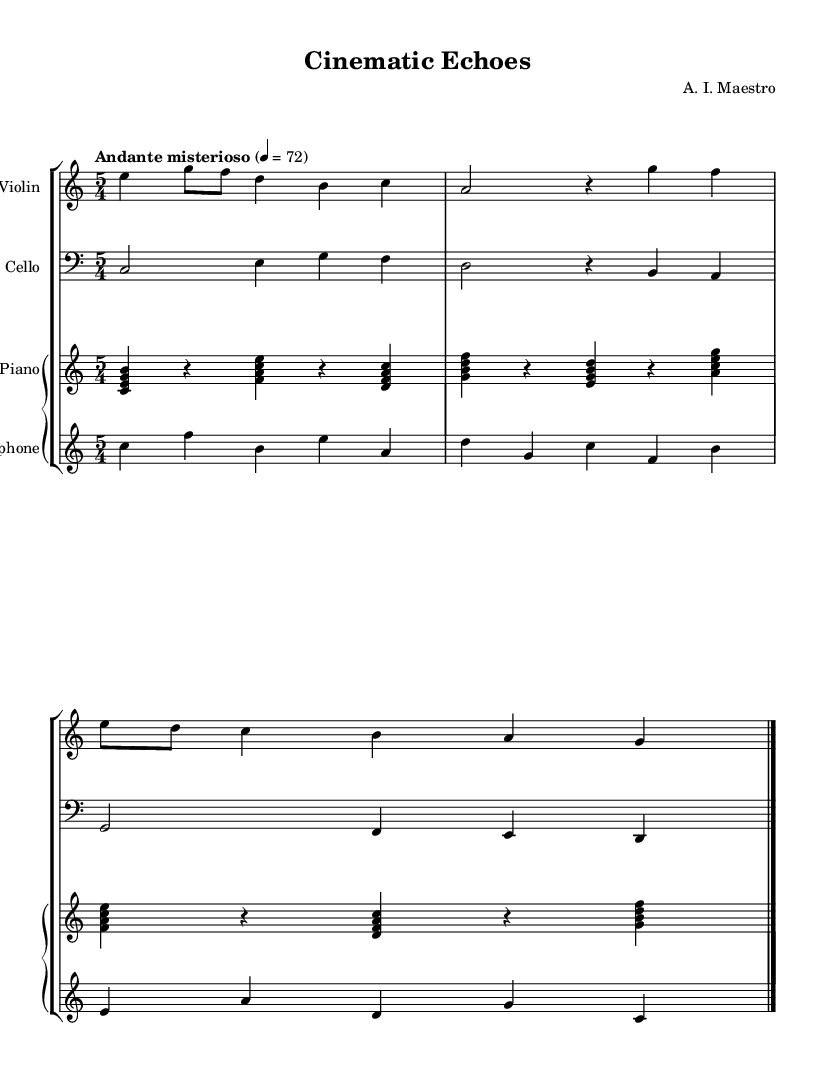What is the time signature of this music? The time signature is indicated at the beginning of the piece, written as "5/4." This means there are five beats in each measure, and a quarter note receives one beat.
Answer: 5/4 What is the tempo marking for this composition? The tempo marking is found at the start of the score, which states "Andante misterioso" and indicates a tempo of 72 beats per minute. "Andante" suggests a moderately slow pace.
Answer: Andante misterioso How many instruments are featured in this composition? The score displays four staves, each representing an instrument, specifically violin, cello, prepared piano, and vibraphone. This indicates there are four instruments used in the performance.
Answer: Four What is the clef used for the cello part? The cello part is notated in the bass clef, which is indicated at the start of the cello staff. The bass clef is commonly used for lower-pitched instruments like the cello.
Answer: Bass clef Which instruments are indicated to use pedal sustain? The score specifies that the vibraphone uses pedal sustain, as indicated by the instruction "set Staff.pedalSustainStyle = #'bracket," which shows that sustaining notes is a part of the playing technique for this instrument.
Answer: Vibraphone What is the first note played by the prepared piano? The prepared piano part starts with the note "C," as signified at the beginning of the first measure for that instrument. This is a clear note that can be identified visually on the staff.
Answer: C 